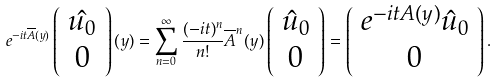<formula> <loc_0><loc_0><loc_500><loc_500>e ^ { - i t \overline { A } ( y ) } \left ( \begin{array} { c } \hat { u _ { 0 } } \\ 0 \end{array} \right ) ( y ) = \sum _ { n = 0 } ^ { \infty } \frac { ( - i t ) ^ { n } } { n ! } \overline { A } ^ { n } ( y ) \left ( \begin{array} { c } \hat { u } _ { 0 } \\ 0 \end{array} \right ) = \left ( \begin{array} { c } e ^ { - i t A ( y ) } \hat { u } _ { 0 } \\ 0 \end{array} \right ) .</formula> 